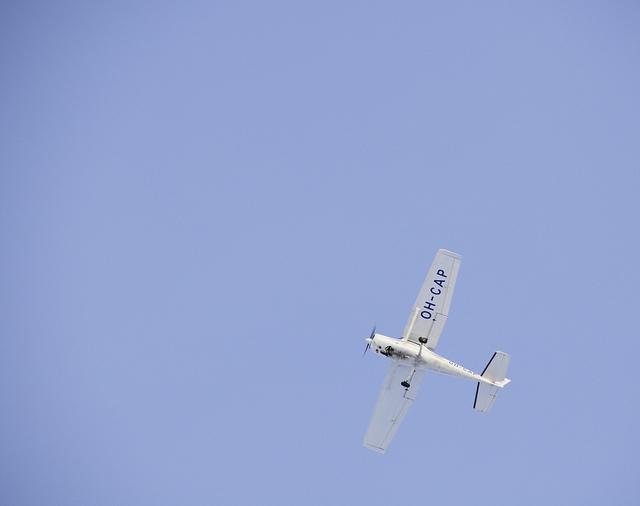Who is driving this vehicle?
Keep it brief. Pilot. Is the plane about to crash?
Answer briefly. No. What color is the bottom of the plane?
Keep it brief. White. Is this a commercial airline plane?
Quick response, please. No. 